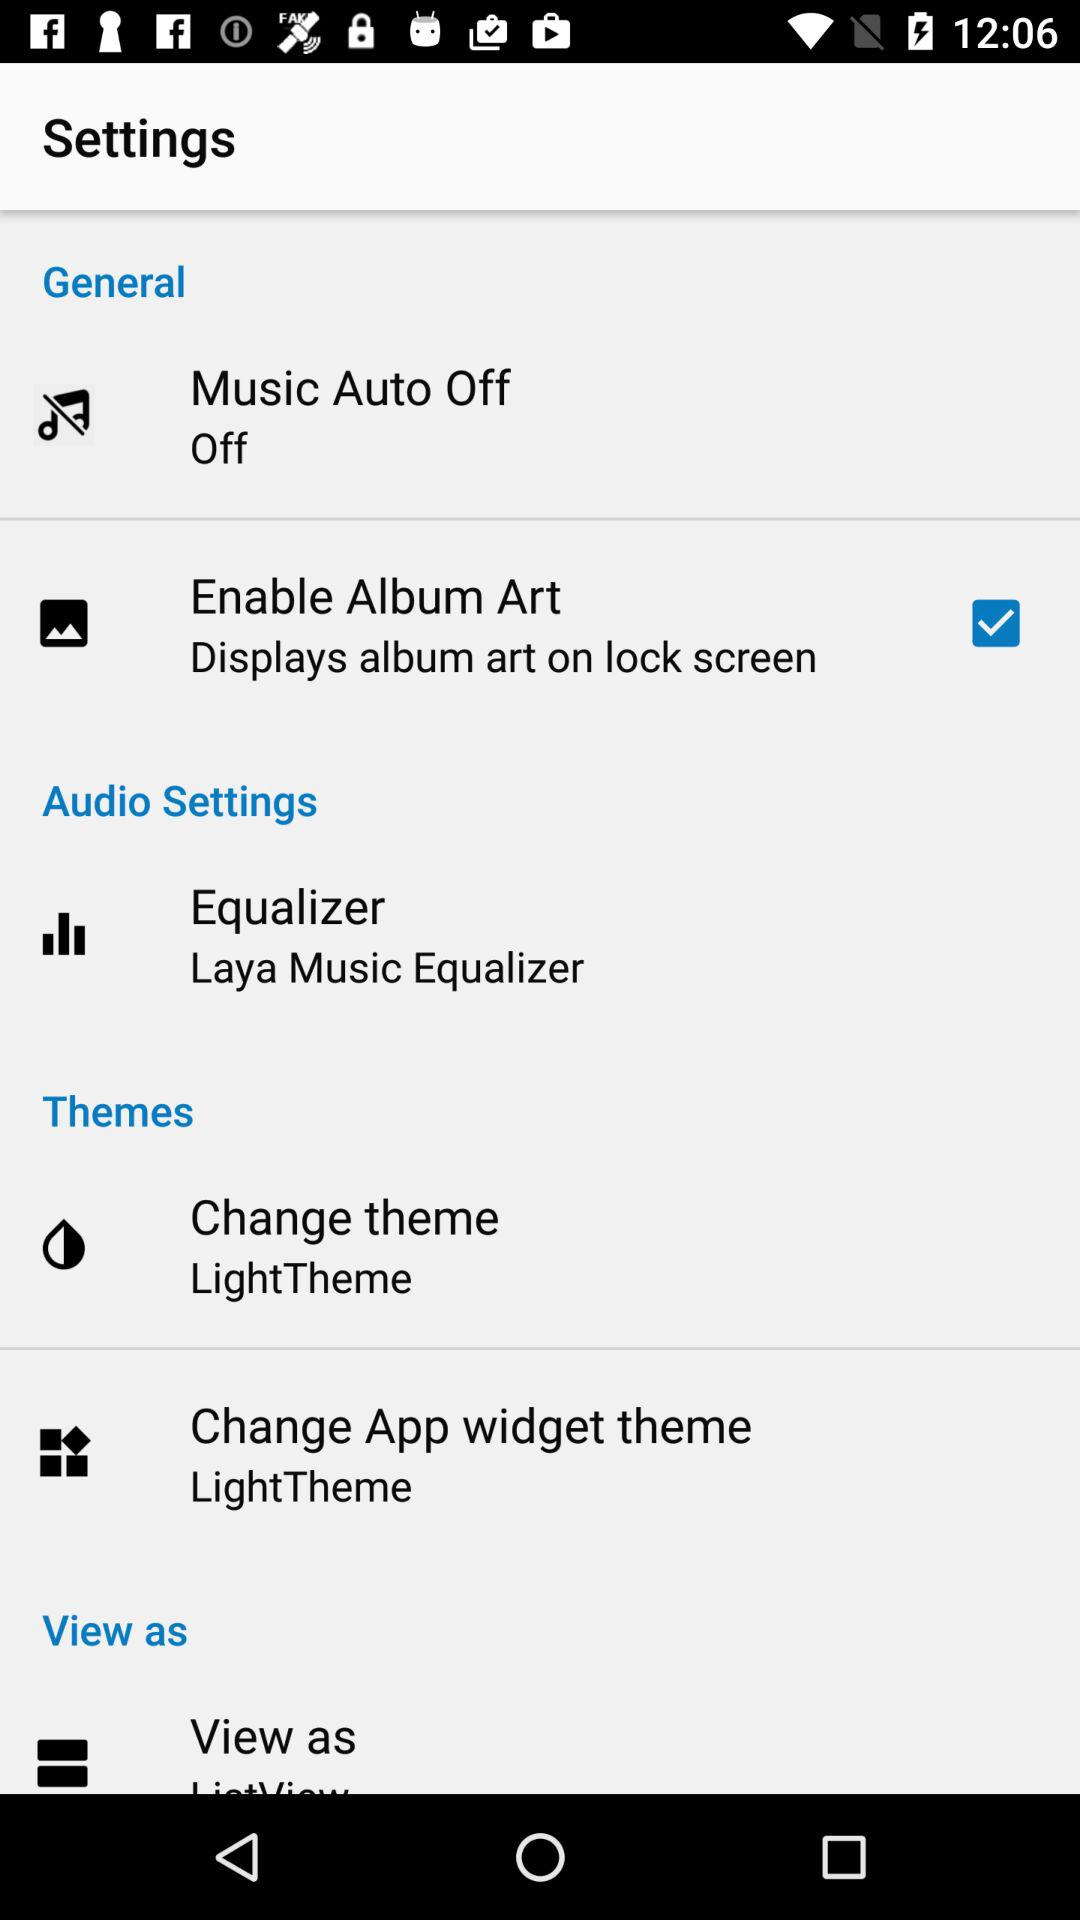How many items are in the settings menu?
Answer the question using a single word or phrase. 6 